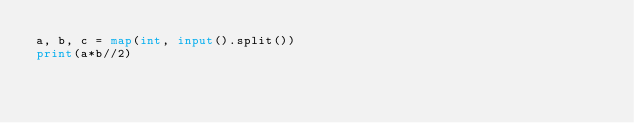<code> <loc_0><loc_0><loc_500><loc_500><_Python_>a, b, c = map(int, input().split())
print(a*b//2)
</code> 